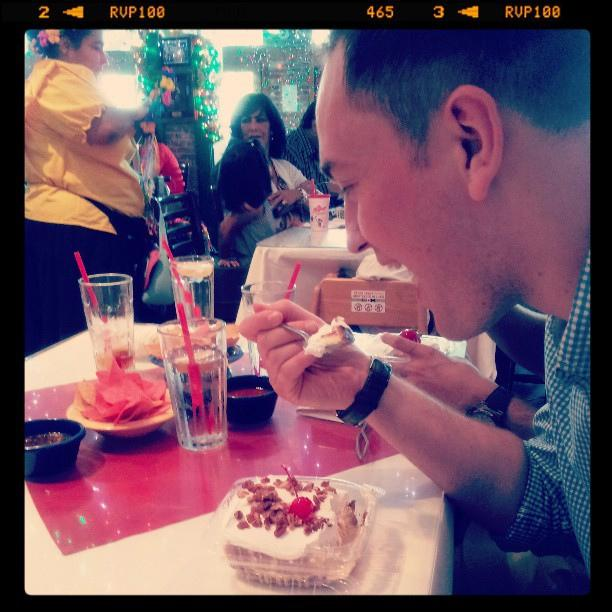What is the red object in the food the man is eating? Please explain your reasoning. cherry. The red food is a cherry on the whipped cream. 